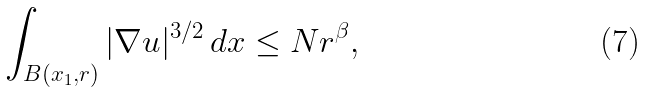<formula> <loc_0><loc_0><loc_500><loc_500>\int _ { B ( x _ { 1 } , r ) } | \nabla u | ^ { 3 / 2 } \, d x \leq N r ^ { \beta } ,</formula> 